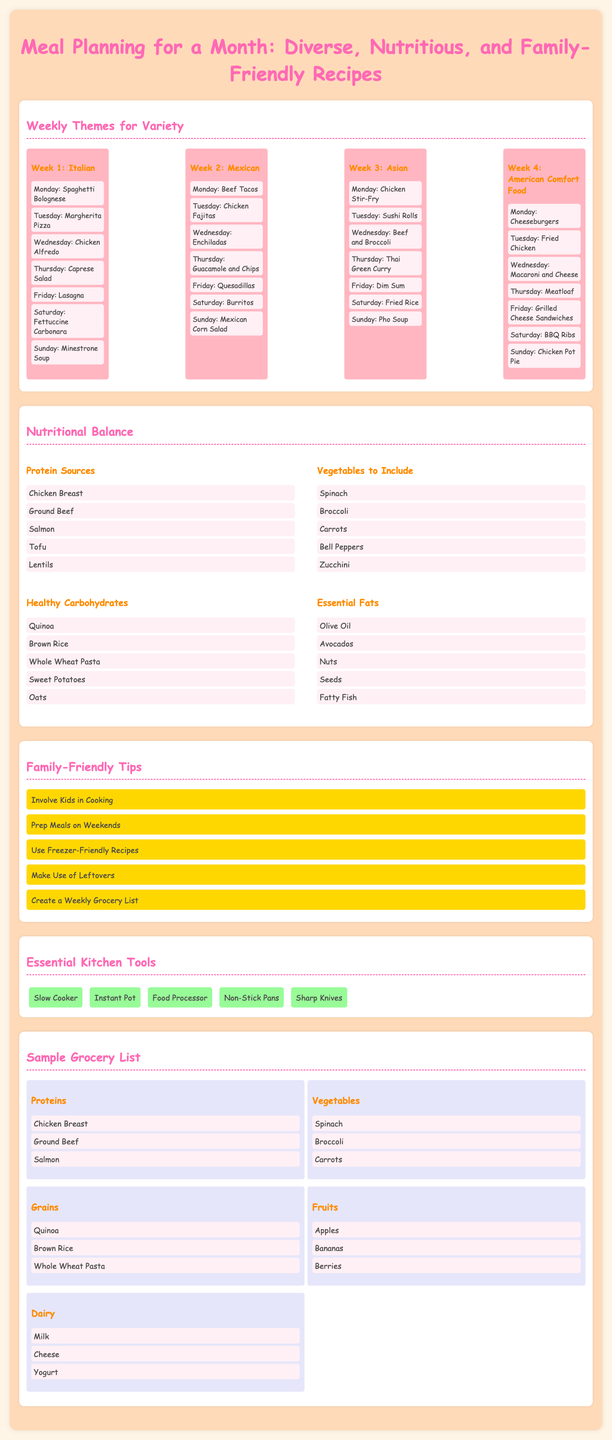What is the theme for Week 3? Week 3's theme is specifically labeled to provide variety in meal options, which is Asian.
Answer: Asian How many different proteins are listed? The document lists various protein sources, including Chicken Breast, Ground Beef, Salmon, Tofu, and Lentils, totaling five.
Answer: 5 What meal is suggested for Friday in Week 2? The document outlines each day's meals specifically, where Friday for Week 2 is Quesadillas.
Answer: Quesadillas Name one essential kitchen tool mentioned. The document specifically lists tools, and one of them is a Slow Cooker, which is essential for meal preparation.
Answer: Slow Cooker What is the purpose of the Family-Friendly Tips section? This section provides strategic advice to help families manage their meal planning, emphasizing things such as involving kids and meal prep.
Answer: Meal management Which vegetable is included in the grocery list? The document contains a variety of grocery items, and Spinach is one of the vegetables mentioned specifically.
Answer: Spinach What is included in the nutritional balance under Healthy Carbohydrates? The section categorizes nutritional components, highlighting that Quinoa, Brown Rice, Whole Wheat Pasta, Sweet Potatoes, and Oats are the listed healthy carbohydrates.
Answer: Quinoa, Brown Rice, Whole Wheat Pasta, Sweet Potatoes, Oats How many weeks does the meal plan cover? The section on Weekly Themes clearly states four themed weeks, indicating the structure of the meal planning.
Answer: 4 What meal is proposed for Thursday in Week 1? Thursday's meal in Week 1 is specifically identified in the themed section as Caprese Salad.
Answer: Caprese Salad 